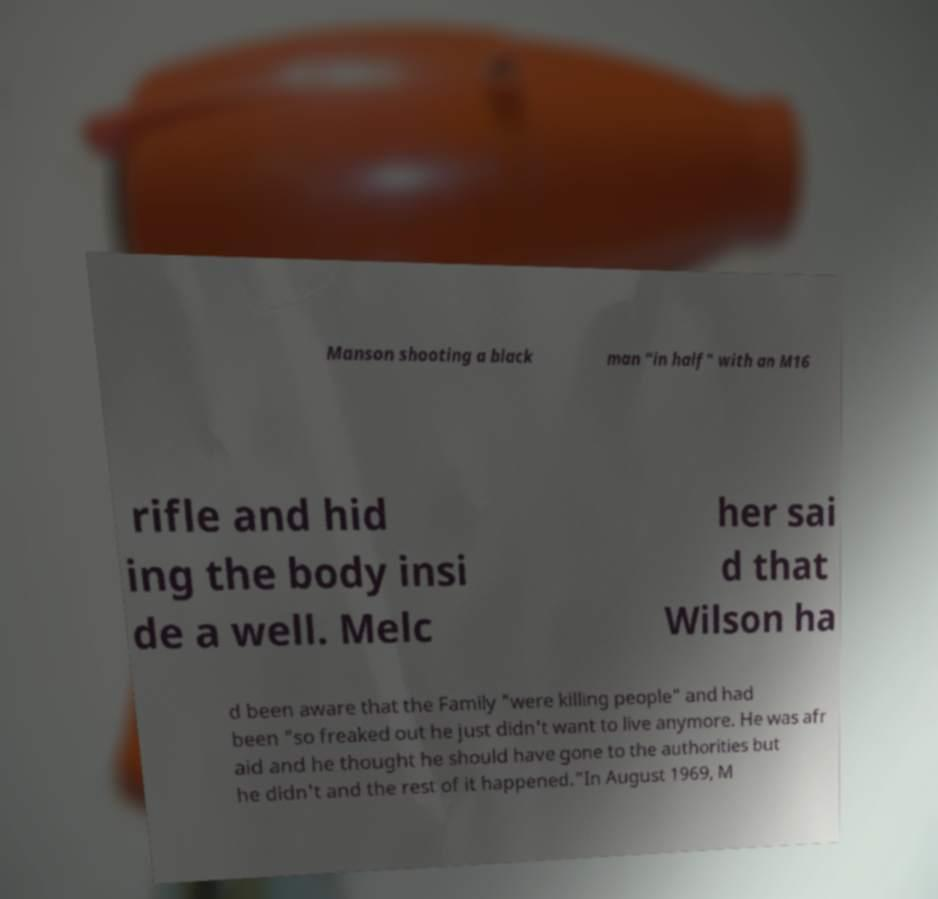Can you accurately transcribe the text from the provided image for me? Manson shooting a black man "in half" with an M16 rifle and hid ing the body insi de a well. Melc her sai d that Wilson ha d been aware that the Family "were killing people" and had been "so freaked out he just didn't want to live anymore. He was afr aid and he thought he should have gone to the authorities but he didn't and the rest of it happened."In August 1969, M 